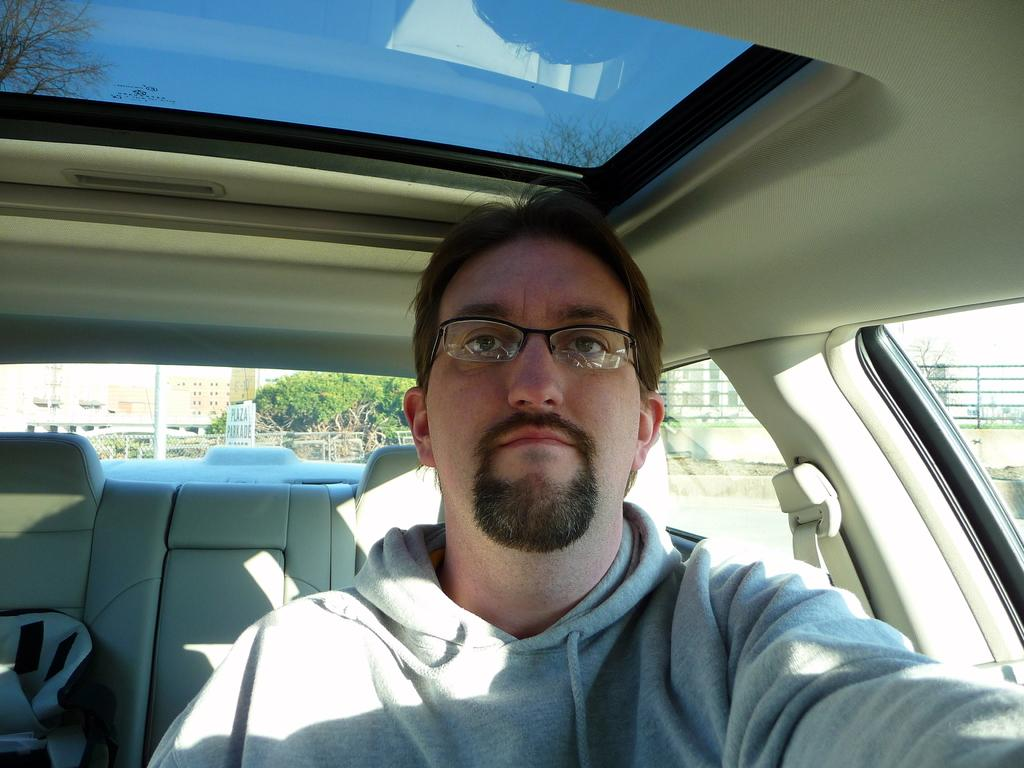What is the person in the image wearing? The person is wearing specs in the image. Where is the person located in the image? The person is sitting inside a car. What can be seen through the car's windows? Trees, buildings, railings, and the sky are visible through the car's windows. What type of loaf is being used to prop up the car's engine in the image? There is no loaf present in the image, and the car's engine is not mentioned. 